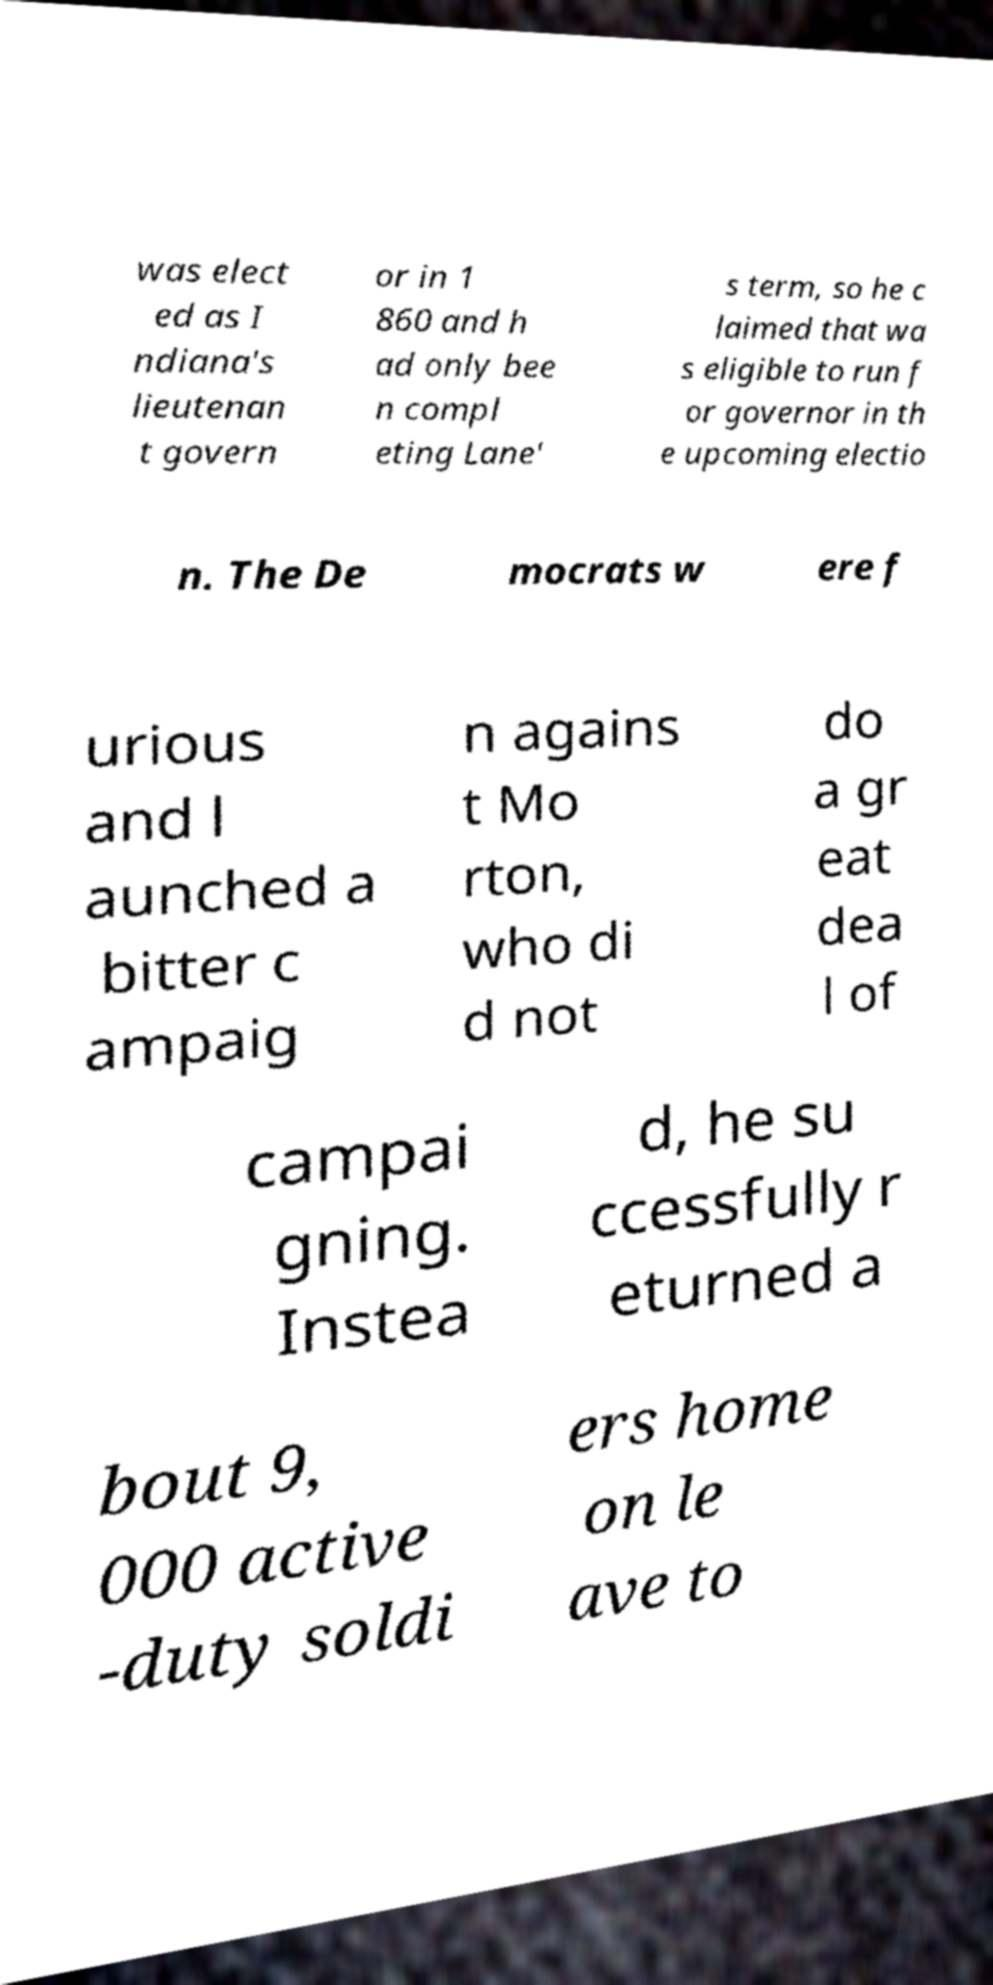Can you accurately transcribe the text from the provided image for me? was elect ed as I ndiana's lieutenan t govern or in 1 860 and h ad only bee n compl eting Lane' s term, so he c laimed that wa s eligible to run f or governor in th e upcoming electio n. The De mocrats w ere f urious and l aunched a bitter c ampaig n agains t Mo rton, who di d not do a gr eat dea l of campai gning. Instea d, he su ccessfully r eturned a bout 9, 000 active -duty soldi ers home on le ave to 